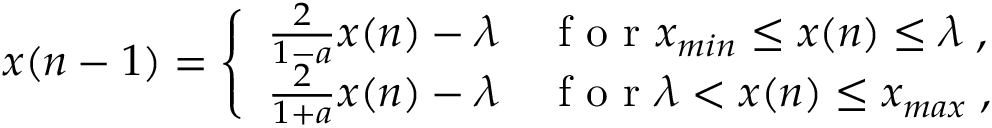<formula> <loc_0><loc_0><loc_500><loc_500>x ( n - 1 ) = \left \{ \begin{array} { l l } { \frac { 2 } { 1 - a } x ( n ) - \lambda } & { f o r x _ { \min } \leq x ( n ) \leq \lambda \, , } \\ { \frac { 2 } { 1 + a } x ( n ) - \lambda } & { f o r \lambda < x ( n ) \leq x _ { \max } \, , } \end{array}</formula> 